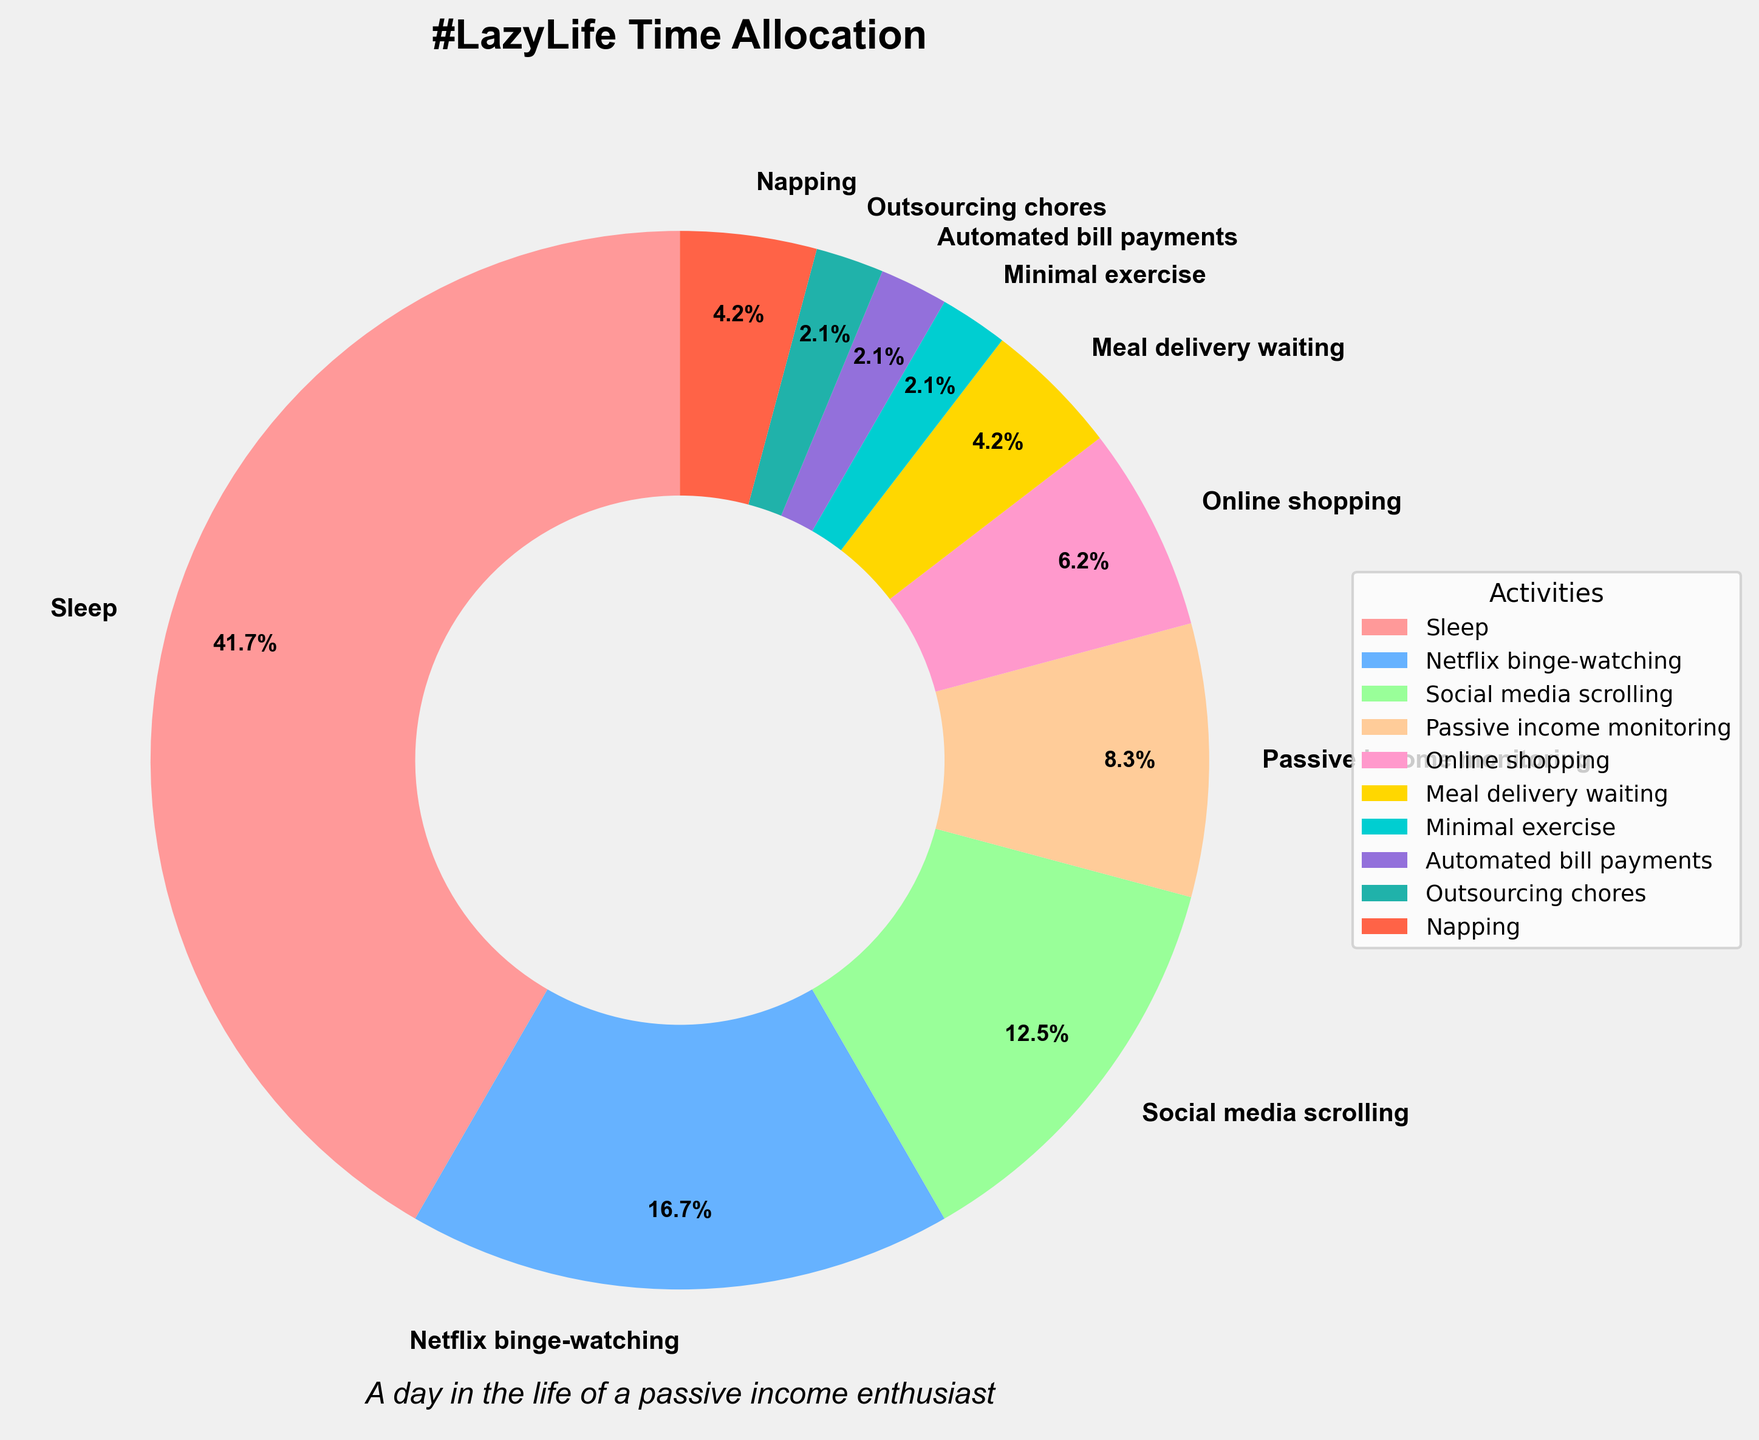What's the total time spent on activities other than sleep? The chart shows that 10 hours are spent on sleep. To find the total time for other activities, subtract the sleep time from the total hours in a day (24 hours): 24 - 10 = 14 hours.
Answer: 14 hours Which activity other than sleep takes the most time? By looking at the different sections of the pie chart, the Netflix binge-watching section is visually the largest after sleep.
Answer: Netflix binge-watching How many hours are spent on activities related to passive income? The activities related to passive income are passive income monitoring (2 hours) and automated bill payments (0.5 hours). Adding these gives 2 + 0.5 = 2.5 hours.
Answer: 2.5 hours Which activity has the smallest time allocation? The smallest section of the pie chart corresponds to minimal exercise, automated bill payments, and outsourcing chores, each taking 0.5 hours.
Answer: Minimal exercise / Automated bill payments / Outsourcing chores Is more time spent on napping or online shopping? Comparing the sections for napping and online shopping, the slice for online shopping (1.5 hours) is larger than the slice for napping (1 hour).
Answer: Online shopping What's the difference in time spent on social media scrolling and meal delivery waiting? Social media scrolling takes 3 hours and meal delivery waiting takes 1 hour. The difference is 3 - 1 = 2 hours.
Answer: 2 hours What percentage of the day is spent on meal delivery waiting? According to the pie chart, meal delivery waiting takes up 1 hour of the day. To find the percentage: (1 hour / 24 hours) * 100% = 4.2%.
Answer: 4.2% Is the time spent on social media greater than the time spent on monitoring passive income and online shopping combined? Social media scrolling is 3 hours. Monitoring passive income and online shopping combined is 2 + 1.5 = 3.5 hours. Since 3 < 3.5, more time is spent on the latter.
Answer: No How many more hours are allocated to Netflix binge-watching compared to minimal exercise? Netflix binge-watching takes 4 hours, and minimal exercise takes 0.5 hours. The difference is 4 - 0.5 = 3.5 hours.
Answer: 3.5 hours What portion of the day is allocated to all the "passive activities" (Netflix binge-watching, social media scrolling, online shopping, and meal delivery waiting) combined? Adding these activities: 4 (Netflix) + 3 (social media) + 1.5 (shopping) + 1 (delivery) = 9.5 hours. Thus, (9.5/24) * 100% = 39.6%.
Answer: 39.6% 